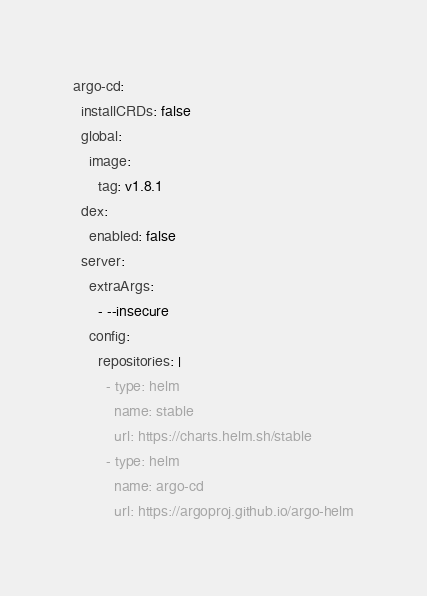<code> <loc_0><loc_0><loc_500><loc_500><_YAML_>argo-cd:
  installCRDs: false
  global:
    image:
      tag: v1.8.1
  dex:
    enabled: false
  server:
    extraArgs:
      - --insecure
    config:
      repositories: |
        - type: helm
          name: stable
          url: https://charts.helm.sh/stable
        - type: helm
          name: argo-cd
          url: https://argoproj.github.io/argo-helm
</code> 